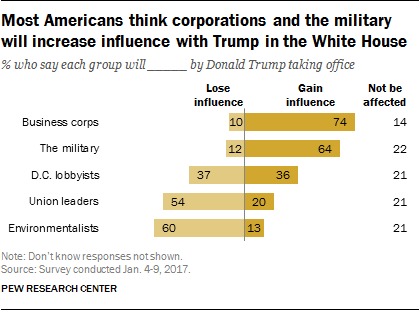Draw attention to some important aspects in this diagram. It is clear that business corporations have a significant impact on society and the economy, and their influence is increasingly felt in various aspects of daily life. A total of 5 entities are expected to lose influence in the chart. 